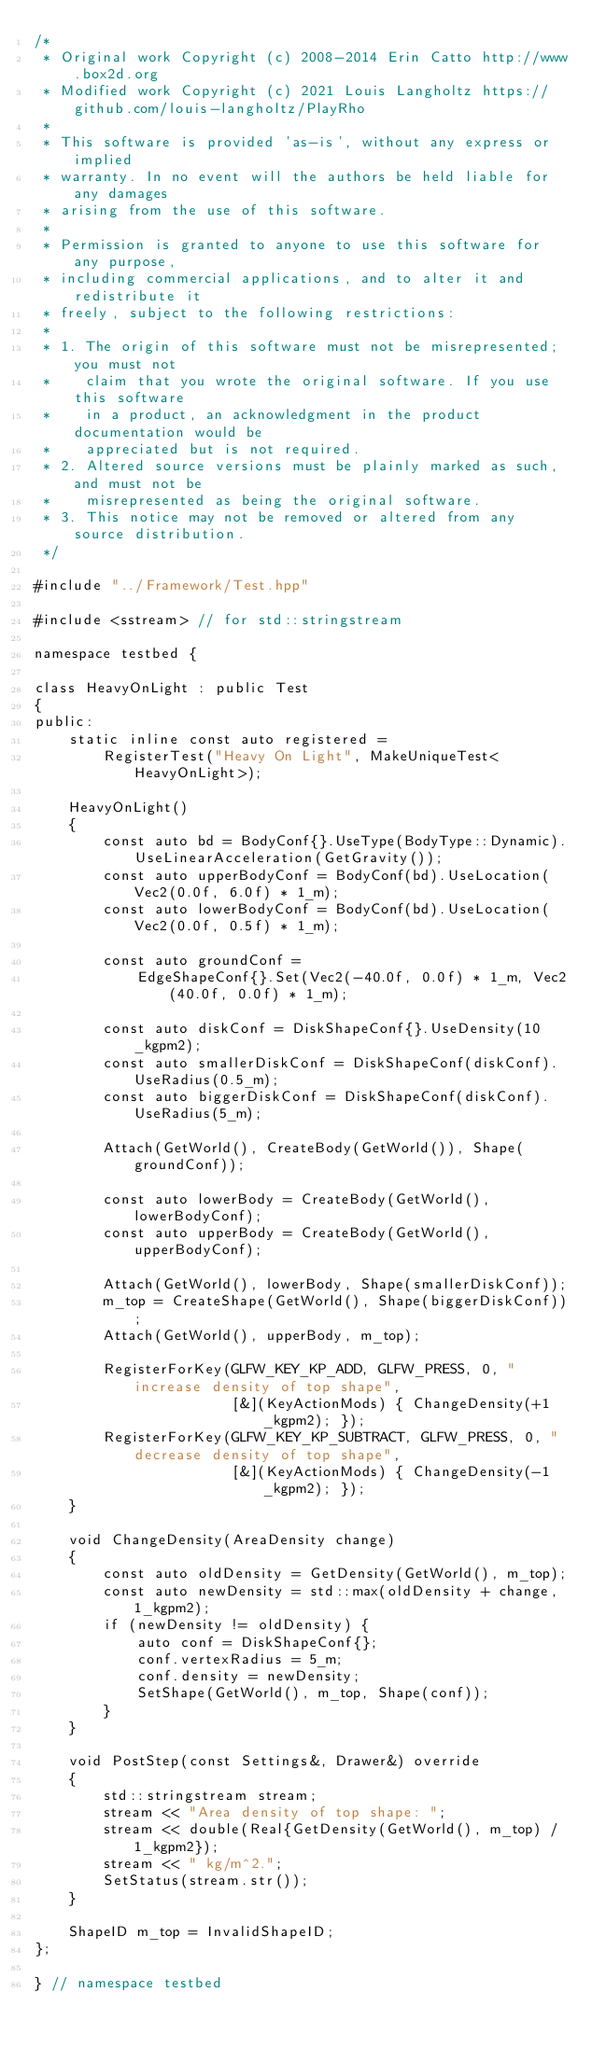<code> <loc_0><loc_0><loc_500><loc_500><_C++_>/*
 * Original work Copyright (c) 2008-2014 Erin Catto http://www.box2d.org
 * Modified work Copyright (c) 2021 Louis Langholtz https://github.com/louis-langholtz/PlayRho
 *
 * This software is provided 'as-is', without any express or implied
 * warranty. In no event will the authors be held liable for any damages
 * arising from the use of this software.
 *
 * Permission is granted to anyone to use this software for any purpose,
 * including commercial applications, and to alter it and redistribute it
 * freely, subject to the following restrictions:
 *
 * 1. The origin of this software must not be misrepresented; you must not
 *    claim that you wrote the original software. If you use this software
 *    in a product, an acknowledgment in the product documentation would be
 *    appreciated but is not required.
 * 2. Altered source versions must be plainly marked as such, and must not be
 *    misrepresented as being the original software.
 * 3. This notice may not be removed or altered from any source distribution.
 */

#include "../Framework/Test.hpp"

#include <sstream> // for std::stringstream

namespace testbed {

class HeavyOnLight : public Test
{
public:
    static inline const auto registered =
        RegisterTest("Heavy On Light", MakeUniqueTest<HeavyOnLight>);

    HeavyOnLight()
    {
        const auto bd = BodyConf{}.UseType(BodyType::Dynamic).UseLinearAcceleration(GetGravity());
        const auto upperBodyConf = BodyConf(bd).UseLocation(Vec2(0.0f, 6.0f) * 1_m);
        const auto lowerBodyConf = BodyConf(bd).UseLocation(Vec2(0.0f, 0.5f) * 1_m);

        const auto groundConf =
            EdgeShapeConf{}.Set(Vec2(-40.0f, 0.0f) * 1_m, Vec2(40.0f, 0.0f) * 1_m);

        const auto diskConf = DiskShapeConf{}.UseDensity(10_kgpm2);
        const auto smallerDiskConf = DiskShapeConf(diskConf).UseRadius(0.5_m);
        const auto biggerDiskConf = DiskShapeConf(diskConf).UseRadius(5_m);

        Attach(GetWorld(), CreateBody(GetWorld()), Shape(groundConf));

        const auto lowerBody = CreateBody(GetWorld(), lowerBodyConf);
        const auto upperBody = CreateBody(GetWorld(), upperBodyConf);

        Attach(GetWorld(), lowerBody, Shape(smallerDiskConf));
        m_top = CreateShape(GetWorld(), Shape(biggerDiskConf));
        Attach(GetWorld(), upperBody, m_top);

        RegisterForKey(GLFW_KEY_KP_ADD, GLFW_PRESS, 0, "increase density of top shape",
                       [&](KeyActionMods) { ChangeDensity(+1_kgpm2); });
        RegisterForKey(GLFW_KEY_KP_SUBTRACT, GLFW_PRESS, 0, "decrease density of top shape",
                       [&](KeyActionMods) { ChangeDensity(-1_kgpm2); });
    }

    void ChangeDensity(AreaDensity change)
    {
        const auto oldDensity = GetDensity(GetWorld(), m_top);
        const auto newDensity = std::max(oldDensity + change, 1_kgpm2);
        if (newDensity != oldDensity) {
            auto conf = DiskShapeConf{};
            conf.vertexRadius = 5_m;
            conf.density = newDensity;
            SetShape(GetWorld(), m_top, Shape(conf));
        }
    }

    void PostStep(const Settings&, Drawer&) override
    {
        std::stringstream stream;
        stream << "Area density of top shape: ";
        stream << double(Real{GetDensity(GetWorld(), m_top) / 1_kgpm2});
        stream << " kg/m^2.";
        SetStatus(stream.str());
    }

    ShapeID m_top = InvalidShapeID;
};

} // namespace testbed
</code> 